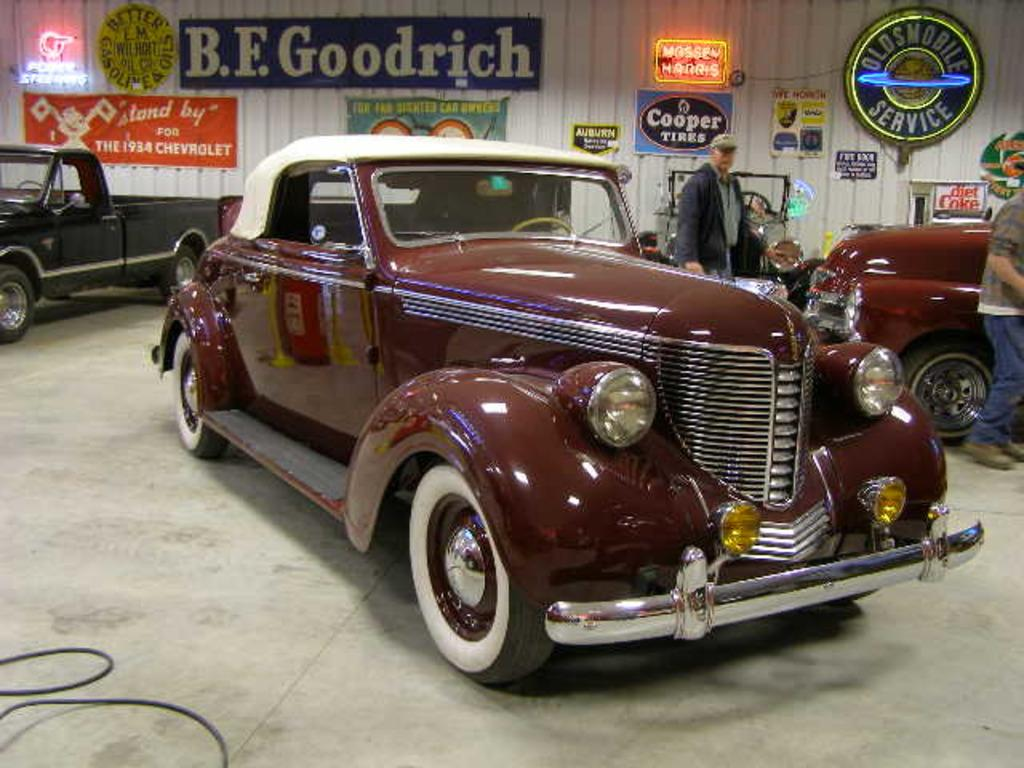Who or what can be seen in the image? There are people and vehicles in the image. Where are the people and vehicles located? They are on the ground. What can be seen in the background of the image? There are posters and other objects in the background. How many snails can be seen crawling on the vehicles in the image? There are no snails visible in the image; it only features people and vehicles on the ground. What type of cord is used to connect the vehicles in the image? There is no cord connecting the vehicles in the image; they are simply parked or moving on the ground. 